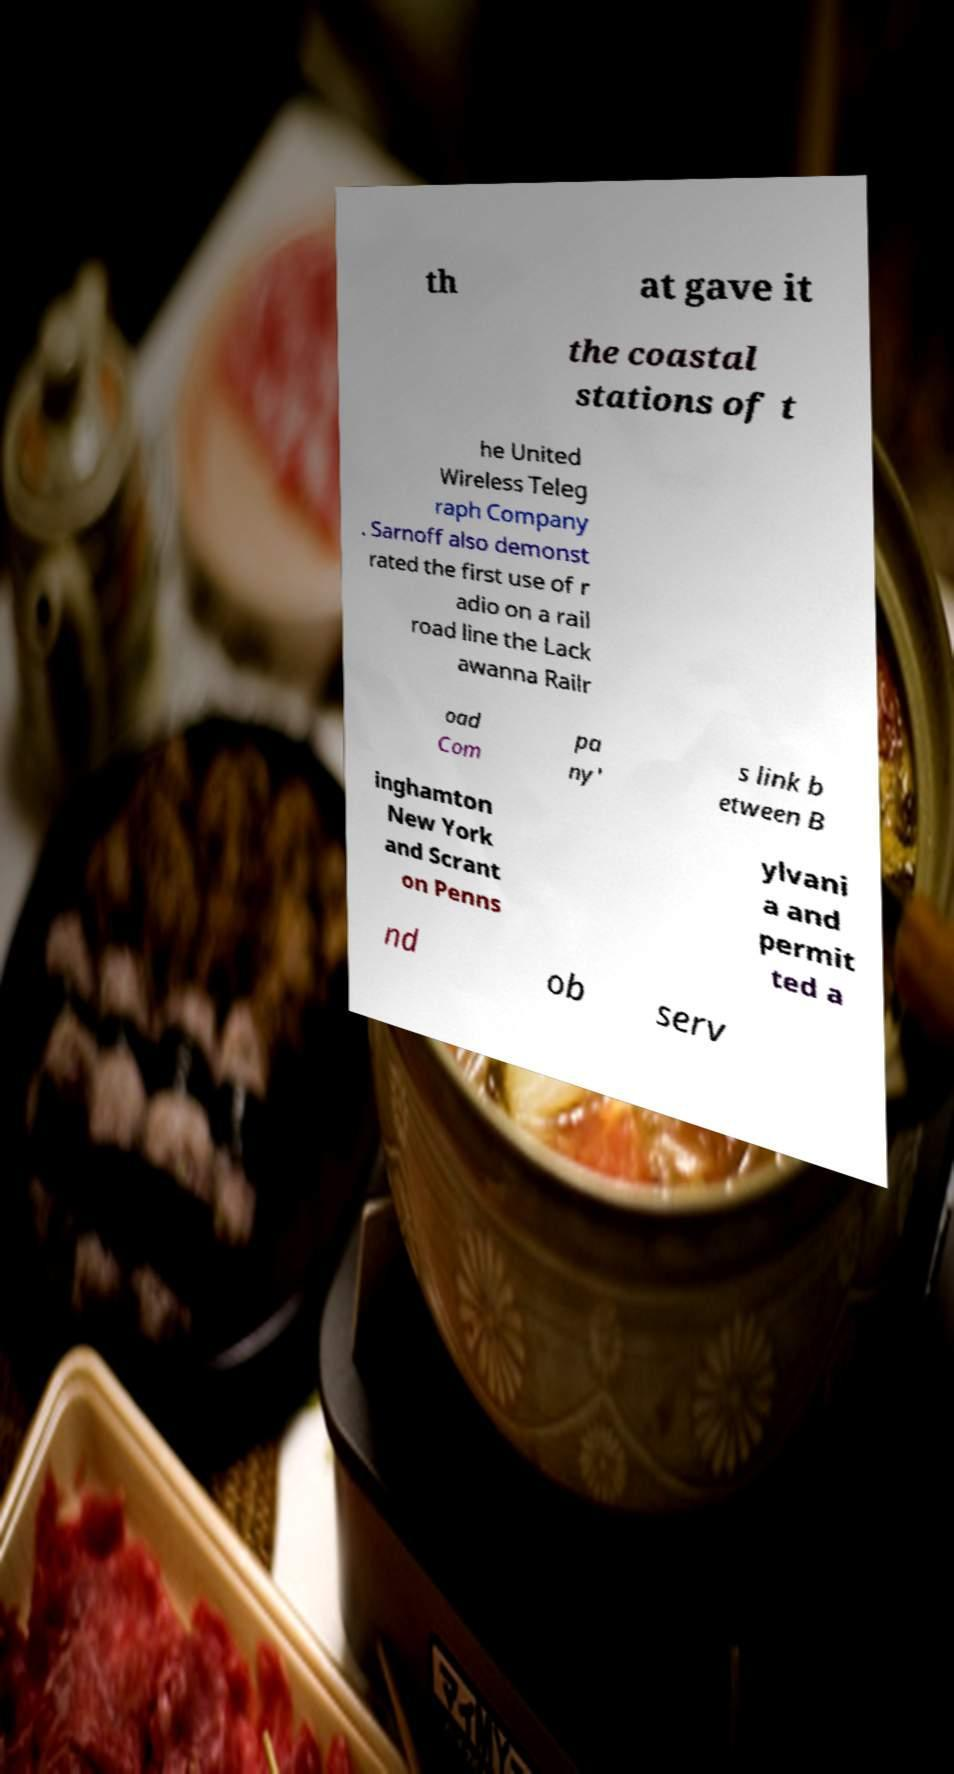Please identify and transcribe the text found in this image. th at gave it the coastal stations of t he United Wireless Teleg raph Company . Sarnoff also demonst rated the first use of r adio on a rail road line the Lack awanna Railr oad Com pa ny' s link b etween B inghamton New York and Scrant on Penns ylvani a and permit ted a nd ob serv 